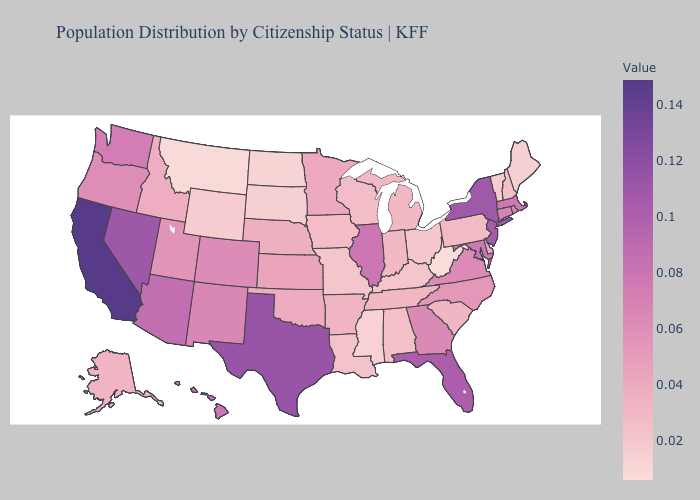Does West Virginia have the lowest value in the USA?
Keep it brief. Yes. Does California have the highest value in the West?
Give a very brief answer. Yes. Among the states that border Illinois , does Wisconsin have the highest value?
Short answer required. No. Does Washington have a higher value than Delaware?
Write a very short answer. Yes. Among the states that border Kentucky , which have the lowest value?
Quick response, please. West Virginia. Which states have the lowest value in the Northeast?
Concise answer only. Maine. 